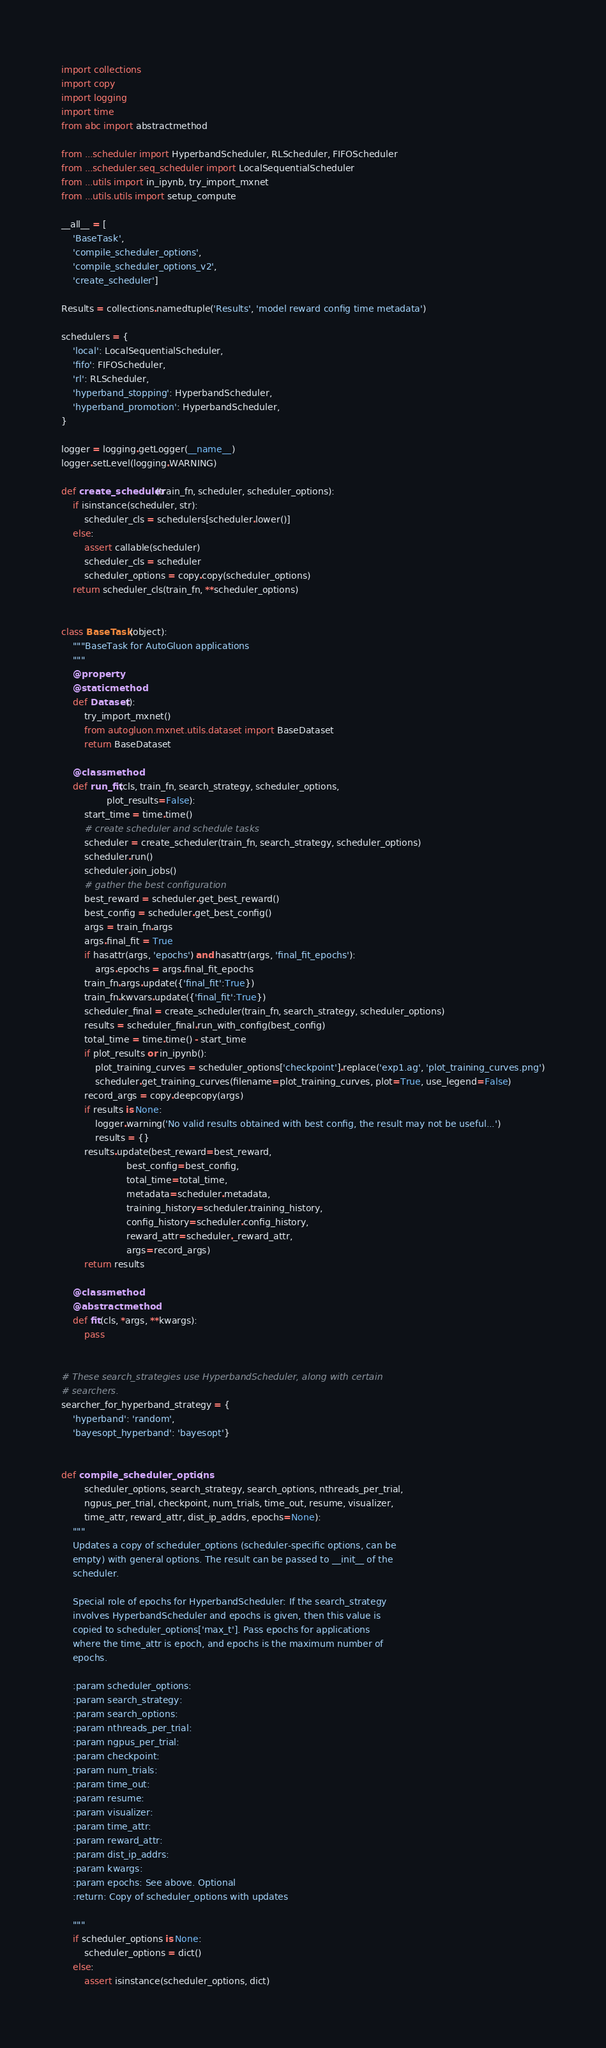<code> <loc_0><loc_0><loc_500><loc_500><_Python_>import collections
import copy
import logging
import time
from abc import abstractmethod

from ...scheduler import HyperbandScheduler, RLScheduler, FIFOScheduler
from ...scheduler.seq_scheduler import LocalSequentialScheduler
from ...utils import in_ipynb, try_import_mxnet
from ...utils.utils import setup_compute

__all__ = [
    'BaseTask',
    'compile_scheduler_options',
    'compile_scheduler_options_v2',
    'create_scheduler']

Results = collections.namedtuple('Results', 'model reward config time metadata')

schedulers = {
    'local': LocalSequentialScheduler,
    'fifo': FIFOScheduler,
    'rl': RLScheduler,
    'hyperband_stopping': HyperbandScheduler,
    'hyperband_promotion': HyperbandScheduler,
}

logger = logging.getLogger(__name__)
logger.setLevel(logging.WARNING)

def create_scheduler(train_fn, scheduler, scheduler_options):
    if isinstance(scheduler, str):
        scheduler_cls = schedulers[scheduler.lower()]
    else:
        assert callable(scheduler)
        scheduler_cls = scheduler
        scheduler_options = copy.copy(scheduler_options)
    return scheduler_cls(train_fn, **scheduler_options)


class BaseTask(object):
    """BaseTask for AutoGluon applications
    """
    @property
    @staticmethod
    def Dataset():
        try_import_mxnet()
        from autogluon.mxnet.utils.dataset import BaseDataset
        return BaseDataset

    @classmethod
    def run_fit(cls, train_fn, search_strategy, scheduler_options,
                plot_results=False):
        start_time = time.time()
        # create scheduler and schedule tasks
        scheduler = create_scheduler(train_fn, search_strategy, scheduler_options)
        scheduler.run()
        scheduler.join_jobs()
        # gather the best configuration
        best_reward = scheduler.get_best_reward()
        best_config = scheduler.get_best_config()
        args = train_fn.args
        args.final_fit = True
        if hasattr(args, 'epochs') and hasattr(args, 'final_fit_epochs'):
            args.epochs = args.final_fit_epochs
        train_fn.args.update({'final_fit':True})
        train_fn.kwvars.update({'final_fit':True})
        scheduler_final = create_scheduler(train_fn, search_strategy, scheduler_options)
        results = scheduler_final.run_with_config(best_config)
        total_time = time.time() - start_time
        if plot_results or in_ipynb():
            plot_training_curves = scheduler_options['checkpoint'].replace('exp1.ag', 'plot_training_curves.png')
            scheduler.get_training_curves(filename=plot_training_curves, plot=True, use_legend=False)
        record_args = copy.deepcopy(args)
        if results is None:
            logger.warning('No valid results obtained with best config, the result may not be useful...')
            results = {}
        results.update(best_reward=best_reward,
                       best_config=best_config,
                       total_time=total_time,
                       metadata=scheduler.metadata,
                       training_history=scheduler.training_history,
                       config_history=scheduler.config_history,
                       reward_attr=scheduler._reward_attr,
                       args=record_args)
        return results

    @classmethod
    @abstractmethod
    def fit(cls, *args, **kwargs):
        pass


# These search_strategies use HyperbandScheduler, along with certain
# searchers.
searcher_for_hyperband_strategy = {
    'hyperband': 'random',
    'bayesopt_hyperband': 'bayesopt'}


def compile_scheduler_options(
        scheduler_options, search_strategy, search_options, nthreads_per_trial,
        ngpus_per_trial, checkpoint, num_trials, time_out, resume, visualizer,
        time_attr, reward_attr, dist_ip_addrs, epochs=None):
    """
    Updates a copy of scheduler_options (scheduler-specific options, can be
    empty) with general options. The result can be passed to __init__ of the
    scheduler.

    Special role of epochs for HyperbandScheduler: If the search_strategy
    involves HyperbandScheduler and epochs is given, then this value is
    copied to scheduler_options['max_t']. Pass epochs for applications
    where the time_attr is epoch, and epochs is the maximum number of
    epochs.

    :param scheduler_options:
    :param search_strategy:
    :param search_options:
    :param nthreads_per_trial:
    :param ngpus_per_trial:
    :param checkpoint:
    :param num_trials:
    :param time_out:
    :param resume:
    :param visualizer:
    :param time_attr:
    :param reward_attr:
    :param dist_ip_addrs:
    :param kwargs:
    :param epochs: See above. Optional
    :return: Copy of scheduler_options with updates

    """
    if scheduler_options is None:
        scheduler_options = dict()
    else:
        assert isinstance(scheduler_options, dict)</code> 